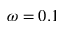Convert formula to latex. <formula><loc_0><loc_0><loc_500><loc_500>\omega = 0 . 1</formula> 